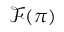Convert formula to latex. <formula><loc_0><loc_0><loc_500><loc_500>{ \mathcal { F } } ( \pi )</formula> 